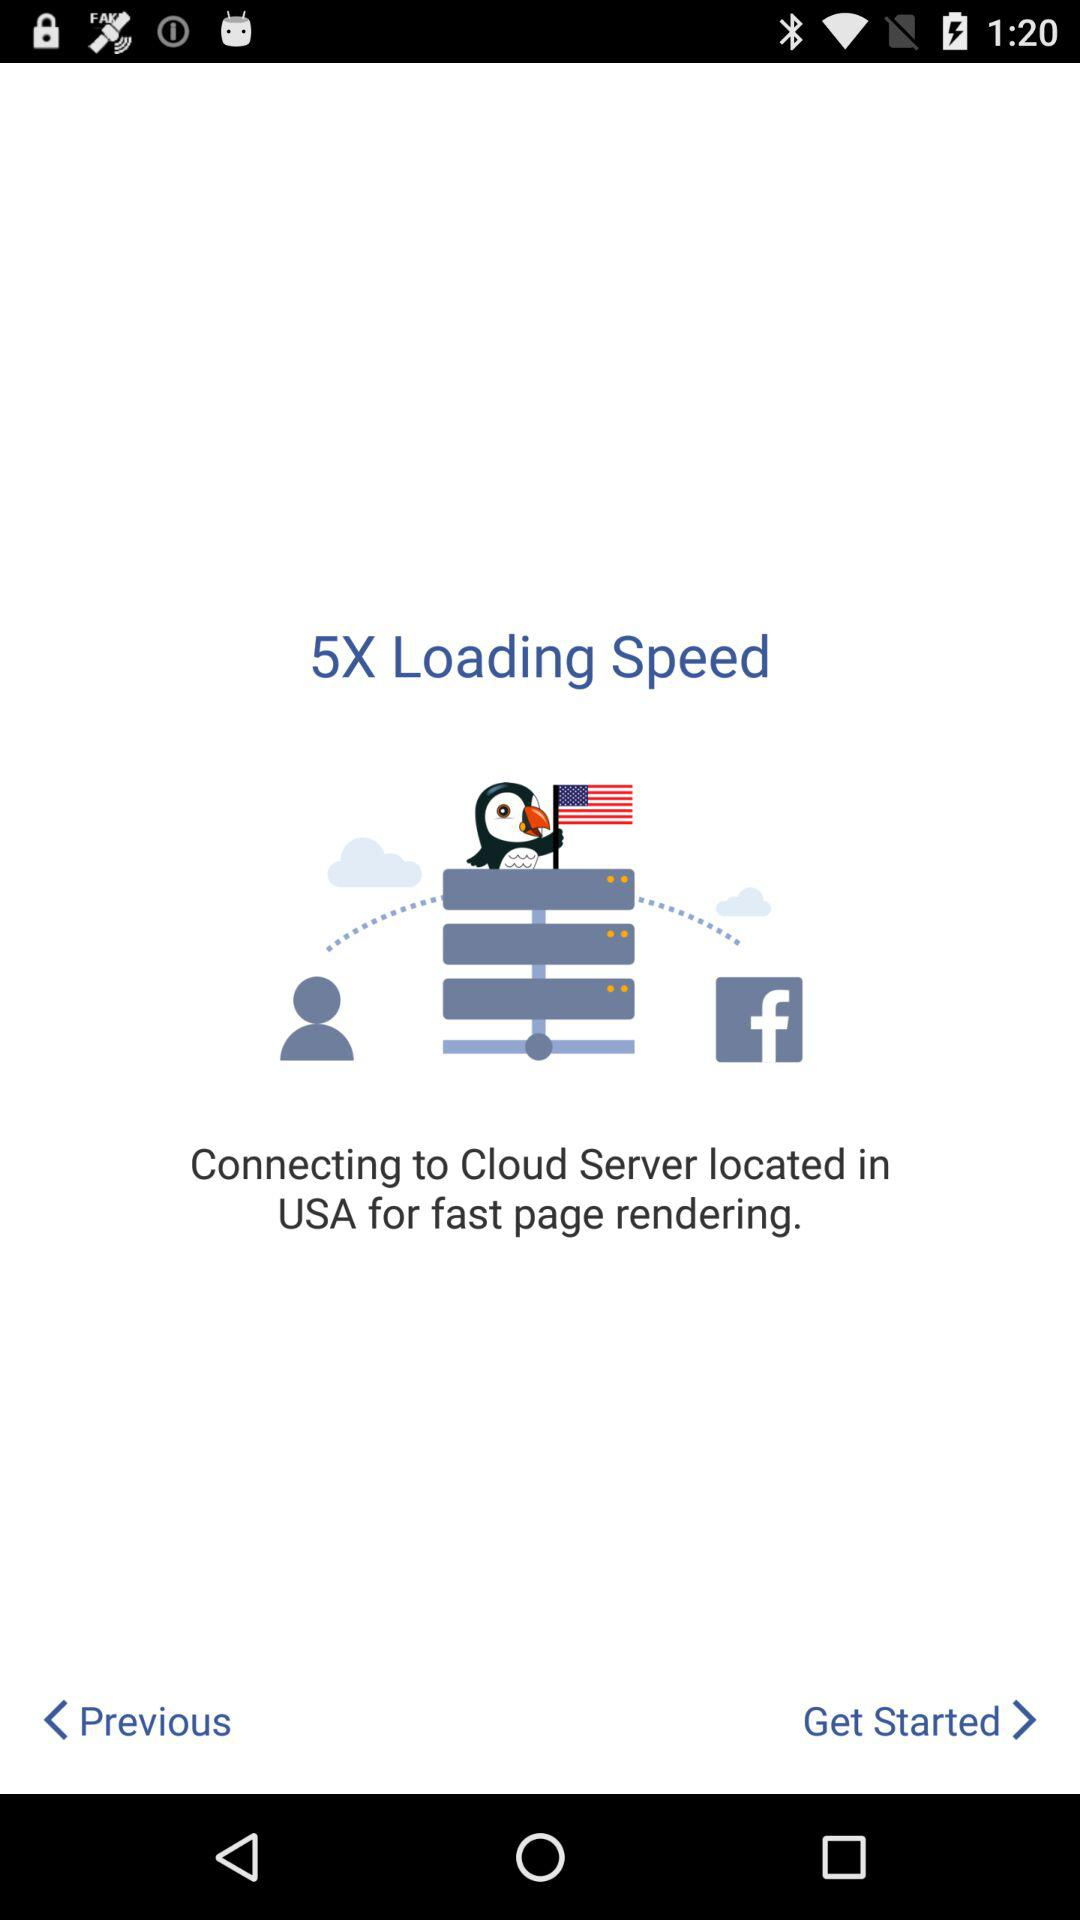Who is this application powered by?
When the provided information is insufficient, respond with <no answer>. <no answer> 